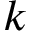<formula> <loc_0><loc_0><loc_500><loc_500>k</formula> 